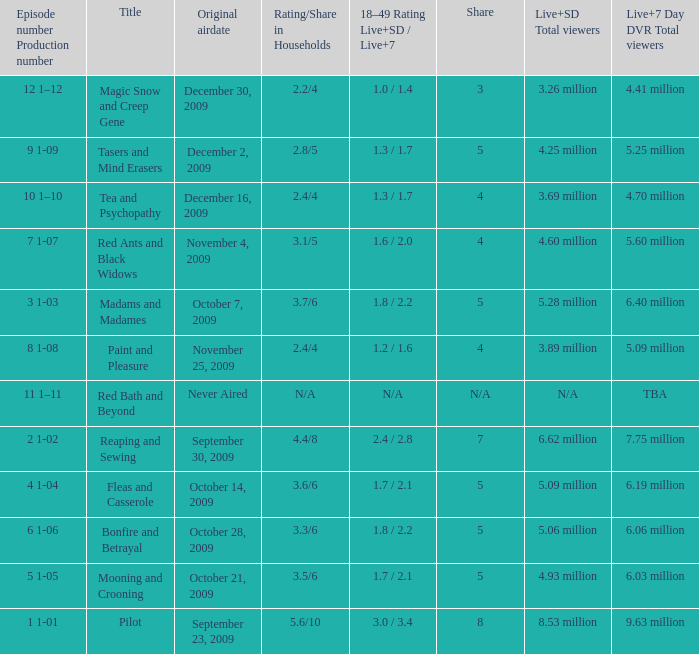When did the episode that had 3.69 million total viewers (Live and SD types combined) first air? December 16, 2009. 